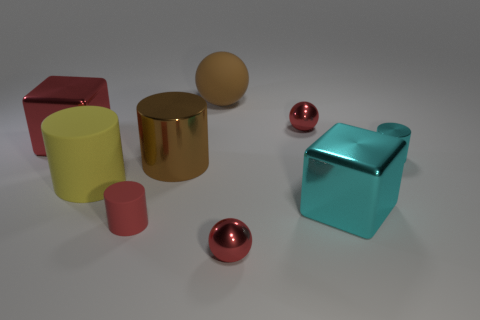Can you describe the texture of the surfaces? Certainly! The surface textures in this image vary. The yellow and red cylinders have a matte finish, the golden sphere and cylinder exhibit a polished metallic texture, and the small red spheres and blue container have a reflective metallic surface that mirrors their surroundings. 